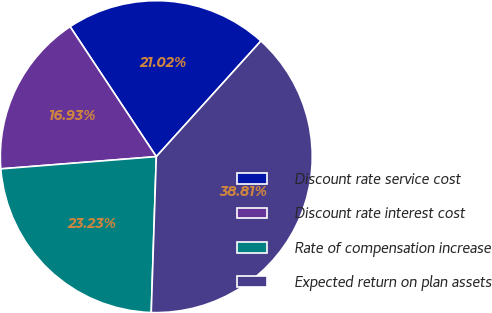Convert chart to OTSL. <chart><loc_0><loc_0><loc_500><loc_500><pie_chart><fcel>Discount rate service cost<fcel>Discount rate interest cost<fcel>Rate of compensation increase<fcel>Expected return on plan assets<nl><fcel>21.02%<fcel>16.93%<fcel>23.23%<fcel>38.81%<nl></chart> 